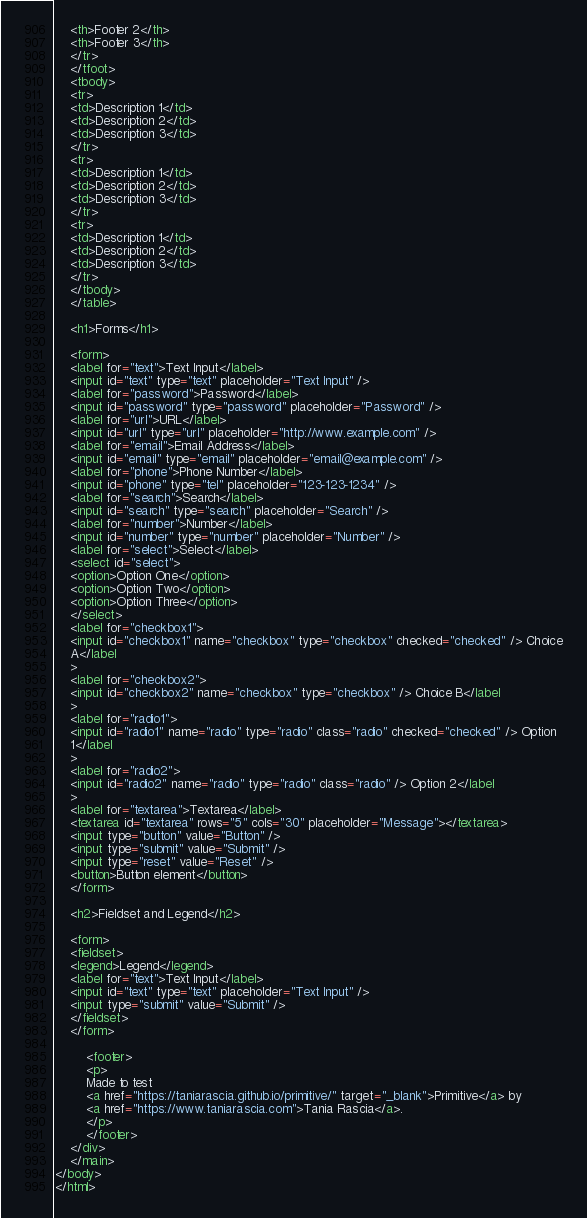Convert code to text. <code><loc_0><loc_0><loc_500><loc_500><_HTML_>	<th>Footer 2</th>
	<th>Footer 3</th>
	</tr>
	</tfoot>
	<tbody>
	<tr>
	<td>Description 1</td>
	<td>Description 2</td>
	<td>Description 3</td>
	</tr>
	<tr>
	<td>Description 1</td>
	<td>Description 2</td>
	<td>Description 3</td>
	</tr>
	<tr>
	<td>Description 1</td>
	<td>Description 2</td>
	<td>Description 3</td>
	</tr>
	</tbody>
	</table>

	<h1>Forms</h1>

	<form>
	<label for="text">Text Input</label>
	<input id="text" type="text" placeholder="Text Input" />
	<label for="password">Password</label>
	<input id="password" type="password" placeholder="Password" />
	<label for="url">URL</label>
	<input id="url" type="url" placeholder="http://www.example.com" />
	<label for="email">Email Address</label>
	<input id="email" type="email" placeholder="email@example.com" />
	<label for="phone">Phone Number</label>
	<input id="phone" type="tel" placeholder="123-123-1234" />
	<label for="search">Search</label>
	<input id="search" type="search" placeholder="Search" />
	<label for="number">Number</label>
	<input id="number" type="number" placeholder="Number" />
	<label for="select">Select</label>
	<select id="select">
	<option>Option One</option>
	<option>Option Two</option>
	<option>Option Three</option>
	</select>
	<label for="checkbox1">
	<input id="checkbox1" name="checkbox" type="checkbox" checked="checked" /> Choice
	A</label
	>
	<label for="checkbox2">
	<input id="checkbox2" name="checkbox" type="checkbox" /> Choice B</label
	>
	<label for="radio1">
	<input id="radio1" name="radio" type="radio" class="radio" checked="checked" /> Option
	1</label
	>
	<label for="radio2">
	<input id="radio2" name="radio" type="radio" class="radio" /> Option 2</label
	>
	<label for="textarea">Textarea</label>
	<textarea id="textarea" rows="5" cols="30" placeholder="Message"></textarea>
	<input type="button" value="Button" />
	<input type="submit" value="Submit" />
	<input type="reset" value="Reset" />
	<button>Button element</button>
	</form>

	<h2>Fieldset and Legend</h2>

	<form>
	<fieldset>
	<legend>Legend</legend>
	<label for="text">Text Input</label>
	<input id="text" type="text" placeholder="Text Input" />
	<input type="submit" value="Submit" />
	</fieldset>
	</form>

		<footer>
		<p>
		Made to test
		<a href="https://taniarascia.github.io/primitive/" target="_blank">Primitive</a> by
		<a href="https://www.taniarascia.com">Tania Rascia</a>.
		</p>
		</footer>
	</div>
	</main>
</body>
</html>
</code> 